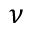Convert formula to latex. <formula><loc_0><loc_0><loc_500><loc_500>\nu</formula> 